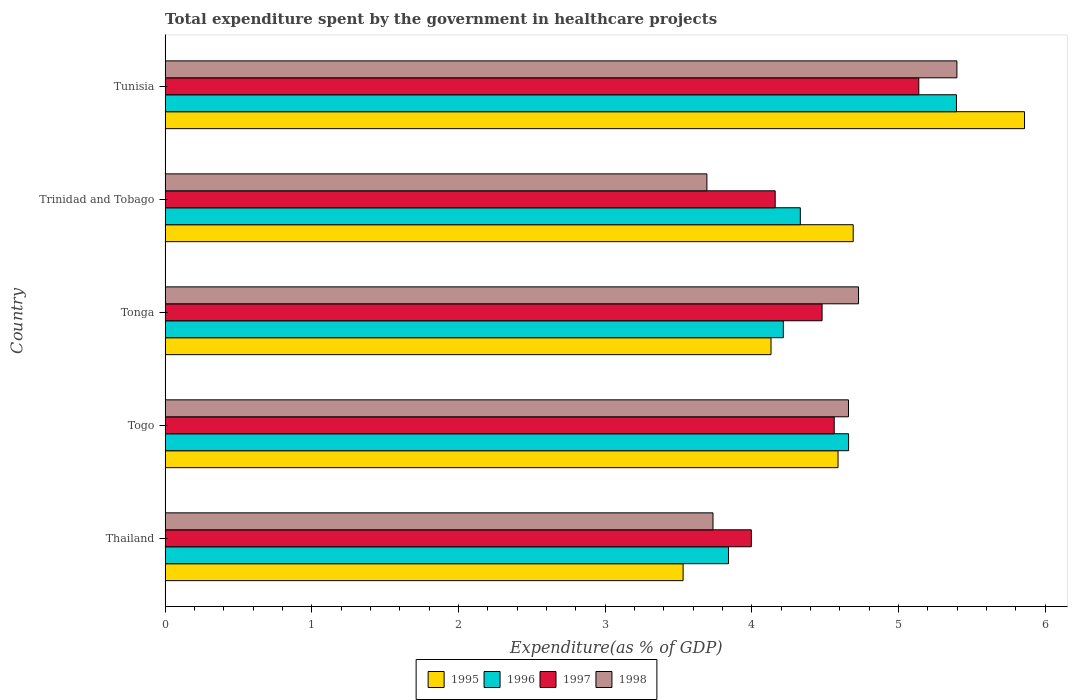How many different coloured bars are there?
Your response must be concise. 4. How many bars are there on the 5th tick from the bottom?
Provide a short and direct response. 4. What is the label of the 2nd group of bars from the top?
Ensure brevity in your answer.  Trinidad and Tobago. What is the total expenditure spent by the government in healthcare projects in 1995 in Togo?
Provide a succinct answer. 4.59. Across all countries, what is the maximum total expenditure spent by the government in healthcare projects in 1997?
Offer a very short reply. 5.14. Across all countries, what is the minimum total expenditure spent by the government in healthcare projects in 1995?
Offer a terse response. 3.53. In which country was the total expenditure spent by the government in healthcare projects in 1998 maximum?
Offer a very short reply. Tunisia. In which country was the total expenditure spent by the government in healthcare projects in 1995 minimum?
Your response must be concise. Thailand. What is the total total expenditure spent by the government in healthcare projects in 1997 in the graph?
Offer a terse response. 22.33. What is the difference between the total expenditure spent by the government in healthcare projects in 1998 in Thailand and that in Tonga?
Your answer should be compact. -0.99. What is the difference between the total expenditure spent by the government in healthcare projects in 1996 in Tunisia and the total expenditure spent by the government in healthcare projects in 1995 in Togo?
Offer a terse response. 0.81. What is the average total expenditure spent by the government in healthcare projects in 1998 per country?
Your response must be concise. 4.44. What is the difference between the total expenditure spent by the government in healthcare projects in 1998 and total expenditure spent by the government in healthcare projects in 1995 in Tonga?
Offer a very short reply. 0.6. In how many countries, is the total expenditure spent by the government in healthcare projects in 1996 greater than 1.6 %?
Your answer should be very brief. 5. What is the ratio of the total expenditure spent by the government in healthcare projects in 1998 in Thailand to that in Trinidad and Tobago?
Your answer should be very brief. 1.01. Is the total expenditure spent by the government in healthcare projects in 1997 in Thailand less than that in Trinidad and Tobago?
Make the answer very short. Yes. What is the difference between the highest and the second highest total expenditure spent by the government in healthcare projects in 1996?
Ensure brevity in your answer.  0.74. What is the difference between the highest and the lowest total expenditure spent by the government in healthcare projects in 1998?
Keep it short and to the point. 1.7. In how many countries, is the total expenditure spent by the government in healthcare projects in 1995 greater than the average total expenditure spent by the government in healthcare projects in 1995 taken over all countries?
Make the answer very short. 3. Is it the case that in every country, the sum of the total expenditure spent by the government in healthcare projects in 1996 and total expenditure spent by the government in healthcare projects in 1997 is greater than the sum of total expenditure spent by the government in healthcare projects in 1998 and total expenditure spent by the government in healthcare projects in 1995?
Provide a succinct answer. Yes. How many bars are there?
Give a very brief answer. 20. Are all the bars in the graph horizontal?
Keep it short and to the point. Yes. How many countries are there in the graph?
Offer a terse response. 5. Are the values on the major ticks of X-axis written in scientific E-notation?
Provide a succinct answer. No. Where does the legend appear in the graph?
Offer a terse response. Bottom center. How many legend labels are there?
Make the answer very short. 4. How are the legend labels stacked?
Offer a terse response. Horizontal. What is the title of the graph?
Your answer should be compact. Total expenditure spent by the government in healthcare projects. What is the label or title of the X-axis?
Keep it short and to the point. Expenditure(as % of GDP). What is the label or title of the Y-axis?
Give a very brief answer. Country. What is the Expenditure(as % of GDP) in 1995 in Thailand?
Make the answer very short. 3.53. What is the Expenditure(as % of GDP) in 1996 in Thailand?
Provide a succinct answer. 3.84. What is the Expenditure(as % of GDP) of 1997 in Thailand?
Give a very brief answer. 4. What is the Expenditure(as % of GDP) in 1998 in Thailand?
Your response must be concise. 3.74. What is the Expenditure(as % of GDP) in 1995 in Togo?
Give a very brief answer. 4.59. What is the Expenditure(as % of GDP) of 1996 in Togo?
Ensure brevity in your answer.  4.66. What is the Expenditure(as % of GDP) in 1997 in Togo?
Your answer should be compact. 4.56. What is the Expenditure(as % of GDP) of 1998 in Togo?
Offer a very short reply. 4.66. What is the Expenditure(as % of GDP) of 1995 in Tonga?
Provide a succinct answer. 4.13. What is the Expenditure(as % of GDP) in 1996 in Tonga?
Ensure brevity in your answer.  4.21. What is the Expenditure(as % of GDP) in 1997 in Tonga?
Your response must be concise. 4.48. What is the Expenditure(as % of GDP) of 1998 in Tonga?
Keep it short and to the point. 4.73. What is the Expenditure(as % of GDP) of 1995 in Trinidad and Tobago?
Your answer should be very brief. 4.69. What is the Expenditure(as % of GDP) of 1996 in Trinidad and Tobago?
Provide a short and direct response. 4.33. What is the Expenditure(as % of GDP) in 1997 in Trinidad and Tobago?
Your answer should be compact. 4.16. What is the Expenditure(as % of GDP) in 1998 in Trinidad and Tobago?
Make the answer very short. 3.69. What is the Expenditure(as % of GDP) of 1995 in Tunisia?
Give a very brief answer. 5.86. What is the Expenditure(as % of GDP) in 1996 in Tunisia?
Offer a terse response. 5.4. What is the Expenditure(as % of GDP) in 1997 in Tunisia?
Provide a succinct answer. 5.14. What is the Expenditure(as % of GDP) in 1998 in Tunisia?
Your answer should be very brief. 5.4. Across all countries, what is the maximum Expenditure(as % of GDP) of 1995?
Your response must be concise. 5.86. Across all countries, what is the maximum Expenditure(as % of GDP) of 1996?
Offer a very short reply. 5.4. Across all countries, what is the maximum Expenditure(as % of GDP) of 1997?
Keep it short and to the point. 5.14. Across all countries, what is the maximum Expenditure(as % of GDP) in 1998?
Offer a very short reply. 5.4. Across all countries, what is the minimum Expenditure(as % of GDP) of 1995?
Offer a terse response. 3.53. Across all countries, what is the minimum Expenditure(as % of GDP) in 1996?
Your answer should be very brief. 3.84. Across all countries, what is the minimum Expenditure(as % of GDP) of 1997?
Make the answer very short. 4. Across all countries, what is the minimum Expenditure(as % of GDP) of 1998?
Make the answer very short. 3.69. What is the total Expenditure(as % of GDP) of 1995 in the graph?
Keep it short and to the point. 22.8. What is the total Expenditure(as % of GDP) of 1996 in the graph?
Provide a succinct answer. 22.44. What is the total Expenditure(as % of GDP) in 1997 in the graph?
Your answer should be compact. 22.33. What is the total Expenditure(as % of GDP) of 1998 in the graph?
Ensure brevity in your answer.  22.21. What is the difference between the Expenditure(as % of GDP) in 1995 in Thailand and that in Togo?
Ensure brevity in your answer.  -1.06. What is the difference between the Expenditure(as % of GDP) in 1996 in Thailand and that in Togo?
Provide a short and direct response. -0.82. What is the difference between the Expenditure(as % of GDP) of 1997 in Thailand and that in Togo?
Your answer should be very brief. -0.56. What is the difference between the Expenditure(as % of GDP) in 1998 in Thailand and that in Togo?
Offer a very short reply. -0.92. What is the difference between the Expenditure(as % of GDP) of 1995 in Thailand and that in Tonga?
Your answer should be very brief. -0.6. What is the difference between the Expenditure(as % of GDP) in 1996 in Thailand and that in Tonga?
Your response must be concise. -0.37. What is the difference between the Expenditure(as % of GDP) of 1997 in Thailand and that in Tonga?
Make the answer very short. -0.48. What is the difference between the Expenditure(as % of GDP) in 1998 in Thailand and that in Tonga?
Make the answer very short. -0.99. What is the difference between the Expenditure(as % of GDP) of 1995 in Thailand and that in Trinidad and Tobago?
Keep it short and to the point. -1.16. What is the difference between the Expenditure(as % of GDP) of 1996 in Thailand and that in Trinidad and Tobago?
Ensure brevity in your answer.  -0.49. What is the difference between the Expenditure(as % of GDP) in 1997 in Thailand and that in Trinidad and Tobago?
Provide a succinct answer. -0.16. What is the difference between the Expenditure(as % of GDP) in 1998 in Thailand and that in Trinidad and Tobago?
Keep it short and to the point. 0.04. What is the difference between the Expenditure(as % of GDP) of 1995 in Thailand and that in Tunisia?
Ensure brevity in your answer.  -2.33. What is the difference between the Expenditure(as % of GDP) of 1996 in Thailand and that in Tunisia?
Your answer should be very brief. -1.55. What is the difference between the Expenditure(as % of GDP) in 1997 in Thailand and that in Tunisia?
Ensure brevity in your answer.  -1.14. What is the difference between the Expenditure(as % of GDP) in 1998 in Thailand and that in Tunisia?
Provide a short and direct response. -1.66. What is the difference between the Expenditure(as % of GDP) in 1995 in Togo and that in Tonga?
Your answer should be compact. 0.46. What is the difference between the Expenditure(as % of GDP) in 1996 in Togo and that in Tonga?
Keep it short and to the point. 0.44. What is the difference between the Expenditure(as % of GDP) of 1997 in Togo and that in Tonga?
Provide a succinct answer. 0.08. What is the difference between the Expenditure(as % of GDP) of 1998 in Togo and that in Tonga?
Make the answer very short. -0.07. What is the difference between the Expenditure(as % of GDP) of 1995 in Togo and that in Trinidad and Tobago?
Your answer should be compact. -0.1. What is the difference between the Expenditure(as % of GDP) in 1996 in Togo and that in Trinidad and Tobago?
Provide a succinct answer. 0.33. What is the difference between the Expenditure(as % of GDP) of 1997 in Togo and that in Trinidad and Tobago?
Your answer should be compact. 0.4. What is the difference between the Expenditure(as % of GDP) in 1998 in Togo and that in Trinidad and Tobago?
Provide a short and direct response. 0.97. What is the difference between the Expenditure(as % of GDP) in 1995 in Togo and that in Tunisia?
Keep it short and to the point. -1.27. What is the difference between the Expenditure(as % of GDP) in 1996 in Togo and that in Tunisia?
Offer a terse response. -0.74. What is the difference between the Expenditure(as % of GDP) of 1997 in Togo and that in Tunisia?
Ensure brevity in your answer.  -0.58. What is the difference between the Expenditure(as % of GDP) in 1998 in Togo and that in Tunisia?
Offer a very short reply. -0.74. What is the difference between the Expenditure(as % of GDP) in 1995 in Tonga and that in Trinidad and Tobago?
Provide a short and direct response. -0.56. What is the difference between the Expenditure(as % of GDP) in 1996 in Tonga and that in Trinidad and Tobago?
Your response must be concise. -0.12. What is the difference between the Expenditure(as % of GDP) of 1997 in Tonga and that in Trinidad and Tobago?
Keep it short and to the point. 0.32. What is the difference between the Expenditure(as % of GDP) of 1998 in Tonga and that in Trinidad and Tobago?
Offer a very short reply. 1.03. What is the difference between the Expenditure(as % of GDP) in 1995 in Tonga and that in Tunisia?
Provide a succinct answer. -1.73. What is the difference between the Expenditure(as % of GDP) in 1996 in Tonga and that in Tunisia?
Your answer should be compact. -1.18. What is the difference between the Expenditure(as % of GDP) in 1997 in Tonga and that in Tunisia?
Offer a very short reply. -0.66. What is the difference between the Expenditure(as % of GDP) of 1998 in Tonga and that in Tunisia?
Offer a very short reply. -0.67. What is the difference between the Expenditure(as % of GDP) in 1995 in Trinidad and Tobago and that in Tunisia?
Make the answer very short. -1.17. What is the difference between the Expenditure(as % of GDP) in 1996 in Trinidad and Tobago and that in Tunisia?
Keep it short and to the point. -1.06. What is the difference between the Expenditure(as % of GDP) of 1997 in Trinidad and Tobago and that in Tunisia?
Offer a terse response. -0.98. What is the difference between the Expenditure(as % of GDP) in 1998 in Trinidad and Tobago and that in Tunisia?
Give a very brief answer. -1.7. What is the difference between the Expenditure(as % of GDP) of 1995 in Thailand and the Expenditure(as % of GDP) of 1996 in Togo?
Your response must be concise. -1.13. What is the difference between the Expenditure(as % of GDP) of 1995 in Thailand and the Expenditure(as % of GDP) of 1997 in Togo?
Make the answer very short. -1.03. What is the difference between the Expenditure(as % of GDP) in 1995 in Thailand and the Expenditure(as % of GDP) in 1998 in Togo?
Ensure brevity in your answer.  -1.13. What is the difference between the Expenditure(as % of GDP) in 1996 in Thailand and the Expenditure(as % of GDP) in 1997 in Togo?
Give a very brief answer. -0.72. What is the difference between the Expenditure(as % of GDP) of 1996 in Thailand and the Expenditure(as % of GDP) of 1998 in Togo?
Provide a succinct answer. -0.82. What is the difference between the Expenditure(as % of GDP) of 1997 in Thailand and the Expenditure(as % of GDP) of 1998 in Togo?
Offer a terse response. -0.66. What is the difference between the Expenditure(as % of GDP) in 1995 in Thailand and the Expenditure(as % of GDP) in 1996 in Tonga?
Ensure brevity in your answer.  -0.68. What is the difference between the Expenditure(as % of GDP) in 1995 in Thailand and the Expenditure(as % of GDP) in 1997 in Tonga?
Your answer should be compact. -0.95. What is the difference between the Expenditure(as % of GDP) of 1995 in Thailand and the Expenditure(as % of GDP) of 1998 in Tonga?
Give a very brief answer. -1.2. What is the difference between the Expenditure(as % of GDP) in 1996 in Thailand and the Expenditure(as % of GDP) in 1997 in Tonga?
Keep it short and to the point. -0.64. What is the difference between the Expenditure(as % of GDP) in 1996 in Thailand and the Expenditure(as % of GDP) in 1998 in Tonga?
Ensure brevity in your answer.  -0.89. What is the difference between the Expenditure(as % of GDP) in 1997 in Thailand and the Expenditure(as % of GDP) in 1998 in Tonga?
Ensure brevity in your answer.  -0.73. What is the difference between the Expenditure(as % of GDP) of 1995 in Thailand and the Expenditure(as % of GDP) of 1996 in Trinidad and Tobago?
Ensure brevity in your answer.  -0.8. What is the difference between the Expenditure(as % of GDP) of 1995 in Thailand and the Expenditure(as % of GDP) of 1997 in Trinidad and Tobago?
Keep it short and to the point. -0.63. What is the difference between the Expenditure(as % of GDP) in 1995 in Thailand and the Expenditure(as % of GDP) in 1998 in Trinidad and Tobago?
Your answer should be compact. -0.16. What is the difference between the Expenditure(as % of GDP) of 1996 in Thailand and the Expenditure(as % of GDP) of 1997 in Trinidad and Tobago?
Make the answer very short. -0.32. What is the difference between the Expenditure(as % of GDP) in 1996 in Thailand and the Expenditure(as % of GDP) in 1998 in Trinidad and Tobago?
Provide a succinct answer. 0.15. What is the difference between the Expenditure(as % of GDP) in 1997 in Thailand and the Expenditure(as % of GDP) in 1998 in Trinidad and Tobago?
Offer a very short reply. 0.3. What is the difference between the Expenditure(as % of GDP) of 1995 in Thailand and the Expenditure(as % of GDP) of 1996 in Tunisia?
Your response must be concise. -1.86. What is the difference between the Expenditure(as % of GDP) of 1995 in Thailand and the Expenditure(as % of GDP) of 1997 in Tunisia?
Ensure brevity in your answer.  -1.61. What is the difference between the Expenditure(as % of GDP) of 1995 in Thailand and the Expenditure(as % of GDP) of 1998 in Tunisia?
Give a very brief answer. -1.87. What is the difference between the Expenditure(as % of GDP) of 1996 in Thailand and the Expenditure(as % of GDP) of 1997 in Tunisia?
Ensure brevity in your answer.  -1.3. What is the difference between the Expenditure(as % of GDP) in 1996 in Thailand and the Expenditure(as % of GDP) in 1998 in Tunisia?
Ensure brevity in your answer.  -1.56. What is the difference between the Expenditure(as % of GDP) of 1997 in Thailand and the Expenditure(as % of GDP) of 1998 in Tunisia?
Ensure brevity in your answer.  -1.4. What is the difference between the Expenditure(as % of GDP) in 1995 in Togo and the Expenditure(as % of GDP) in 1996 in Tonga?
Your answer should be very brief. 0.37. What is the difference between the Expenditure(as % of GDP) in 1995 in Togo and the Expenditure(as % of GDP) in 1997 in Tonga?
Offer a terse response. 0.11. What is the difference between the Expenditure(as % of GDP) in 1995 in Togo and the Expenditure(as % of GDP) in 1998 in Tonga?
Your response must be concise. -0.14. What is the difference between the Expenditure(as % of GDP) in 1996 in Togo and the Expenditure(as % of GDP) in 1997 in Tonga?
Offer a terse response. 0.18. What is the difference between the Expenditure(as % of GDP) in 1996 in Togo and the Expenditure(as % of GDP) in 1998 in Tonga?
Provide a short and direct response. -0.07. What is the difference between the Expenditure(as % of GDP) in 1997 in Togo and the Expenditure(as % of GDP) in 1998 in Tonga?
Provide a succinct answer. -0.17. What is the difference between the Expenditure(as % of GDP) of 1995 in Togo and the Expenditure(as % of GDP) of 1996 in Trinidad and Tobago?
Ensure brevity in your answer.  0.26. What is the difference between the Expenditure(as % of GDP) of 1995 in Togo and the Expenditure(as % of GDP) of 1997 in Trinidad and Tobago?
Your answer should be compact. 0.43. What is the difference between the Expenditure(as % of GDP) in 1995 in Togo and the Expenditure(as % of GDP) in 1998 in Trinidad and Tobago?
Make the answer very short. 0.89. What is the difference between the Expenditure(as % of GDP) in 1996 in Togo and the Expenditure(as % of GDP) in 1997 in Trinidad and Tobago?
Give a very brief answer. 0.5. What is the difference between the Expenditure(as % of GDP) of 1997 in Togo and the Expenditure(as % of GDP) of 1998 in Trinidad and Tobago?
Your answer should be very brief. 0.87. What is the difference between the Expenditure(as % of GDP) in 1995 in Togo and the Expenditure(as % of GDP) in 1996 in Tunisia?
Your response must be concise. -0.81. What is the difference between the Expenditure(as % of GDP) in 1995 in Togo and the Expenditure(as % of GDP) in 1997 in Tunisia?
Provide a succinct answer. -0.55. What is the difference between the Expenditure(as % of GDP) of 1995 in Togo and the Expenditure(as % of GDP) of 1998 in Tunisia?
Give a very brief answer. -0.81. What is the difference between the Expenditure(as % of GDP) of 1996 in Togo and the Expenditure(as % of GDP) of 1997 in Tunisia?
Give a very brief answer. -0.48. What is the difference between the Expenditure(as % of GDP) of 1996 in Togo and the Expenditure(as % of GDP) of 1998 in Tunisia?
Your answer should be compact. -0.74. What is the difference between the Expenditure(as % of GDP) in 1997 in Togo and the Expenditure(as % of GDP) in 1998 in Tunisia?
Keep it short and to the point. -0.84. What is the difference between the Expenditure(as % of GDP) in 1995 in Tonga and the Expenditure(as % of GDP) in 1996 in Trinidad and Tobago?
Give a very brief answer. -0.2. What is the difference between the Expenditure(as % of GDP) in 1995 in Tonga and the Expenditure(as % of GDP) in 1997 in Trinidad and Tobago?
Your answer should be compact. -0.03. What is the difference between the Expenditure(as % of GDP) in 1995 in Tonga and the Expenditure(as % of GDP) in 1998 in Trinidad and Tobago?
Give a very brief answer. 0.44. What is the difference between the Expenditure(as % of GDP) of 1996 in Tonga and the Expenditure(as % of GDP) of 1997 in Trinidad and Tobago?
Offer a very short reply. 0.06. What is the difference between the Expenditure(as % of GDP) in 1996 in Tonga and the Expenditure(as % of GDP) in 1998 in Trinidad and Tobago?
Give a very brief answer. 0.52. What is the difference between the Expenditure(as % of GDP) of 1997 in Tonga and the Expenditure(as % of GDP) of 1998 in Trinidad and Tobago?
Offer a very short reply. 0.79. What is the difference between the Expenditure(as % of GDP) of 1995 in Tonga and the Expenditure(as % of GDP) of 1996 in Tunisia?
Keep it short and to the point. -1.26. What is the difference between the Expenditure(as % of GDP) of 1995 in Tonga and the Expenditure(as % of GDP) of 1997 in Tunisia?
Offer a very short reply. -1.01. What is the difference between the Expenditure(as % of GDP) in 1995 in Tonga and the Expenditure(as % of GDP) in 1998 in Tunisia?
Your answer should be very brief. -1.27. What is the difference between the Expenditure(as % of GDP) in 1996 in Tonga and the Expenditure(as % of GDP) in 1997 in Tunisia?
Your answer should be very brief. -0.92. What is the difference between the Expenditure(as % of GDP) in 1996 in Tonga and the Expenditure(as % of GDP) in 1998 in Tunisia?
Ensure brevity in your answer.  -1.18. What is the difference between the Expenditure(as % of GDP) of 1997 in Tonga and the Expenditure(as % of GDP) of 1998 in Tunisia?
Make the answer very short. -0.92. What is the difference between the Expenditure(as % of GDP) in 1995 in Trinidad and Tobago and the Expenditure(as % of GDP) in 1996 in Tunisia?
Make the answer very short. -0.7. What is the difference between the Expenditure(as % of GDP) in 1995 in Trinidad and Tobago and the Expenditure(as % of GDP) in 1997 in Tunisia?
Your response must be concise. -0.45. What is the difference between the Expenditure(as % of GDP) of 1995 in Trinidad and Tobago and the Expenditure(as % of GDP) of 1998 in Tunisia?
Ensure brevity in your answer.  -0.71. What is the difference between the Expenditure(as % of GDP) in 1996 in Trinidad and Tobago and the Expenditure(as % of GDP) in 1997 in Tunisia?
Keep it short and to the point. -0.81. What is the difference between the Expenditure(as % of GDP) in 1996 in Trinidad and Tobago and the Expenditure(as % of GDP) in 1998 in Tunisia?
Your response must be concise. -1.07. What is the difference between the Expenditure(as % of GDP) in 1997 in Trinidad and Tobago and the Expenditure(as % of GDP) in 1998 in Tunisia?
Provide a succinct answer. -1.24. What is the average Expenditure(as % of GDP) in 1995 per country?
Your answer should be very brief. 4.56. What is the average Expenditure(as % of GDP) in 1996 per country?
Keep it short and to the point. 4.49. What is the average Expenditure(as % of GDP) in 1997 per country?
Provide a succinct answer. 4.47. What is the average Expenditure(as % of GDP) of 1998 per country?
Ensure brevity in your answer.  4.44. What is the difference between the Expenditure(as % of GDP) in 1995 and Expenditure(as % of GDP) in 1996 in Thailand?
Your answer should be compact. -0.31. What is the difference between the Expenditure(as % of GDP) of 1995 and Expenditure(as % of GDP) of 1997 in Thailand?
Your response must be concise. -0.47. What is the difference between the Expenditure(as % of GDP) in 1995 and Expenditure(as % of GDP) in 1998 in Thailand?
Offer a very short reply. -0.2. What is the difference between the Expenditure(as % of GDP) in 1996 and Expenditure(as % of GDP) in 1997 in Thailand?
Keep it short and to the point. -0.16. What is the difference between the Expenditure(as % of GDP) of 1996 and Expenditure(as % of GDP) of 1998 in Thailand?
Your answer should be compact. 0.11. What is the difference between the Expenditure(as % of GDP) in 1997 and Expenditure(as % of GDP) in 1998 in Thailand?
Keep it short and to the point. 0.26. What is the difference between the Expenditure(as % of GDP) in 1995 and Expenditure(as % of GDP) in 1996 in Togo?
Give a very brief answer. -0.07. What is the difference between the Expenditure(as % of GDP) of 1995 and Expenditure(as % of GDP) of 1997 in Togo?
Offer a very short reply. 0.03. What is the difference between the Expenditure(as % of GDP) in 1995 and Expenditure(as % of GDP) in 1998 in Togo?
Give a very brief answer. -0.07. What is the difference between the Expenditure(as % of GDP) in 1996 and Expenditure(as % of GDP) in 1997 in Togo?
Your answer should be compact. 0.1. What is the difference between the Expenditure(as % of GDP) in 1996 and Expenditure(as % of GDP) in 1998 in Togo?
Keep it short and to the point. 0. What is the difference between the Expenditure(as % of GDP) of 1997 and Expenditure(as % of GDP) of 1998 in Togo?
Your response must be concise. -0.1. What is the difference between the Expenditure(as % of GDP) of 1995 and Expenditure(as % of GDP) of 1996 in Tonga?
Ensure brevity in your answer.  -0.08. What is the difference between the Expenditure(as % of GDP) of 1995 and Expenditure(as % of GDP) of 1997 in Tonga?
Your answer should be very brief. -0.35. What is the difference between the Expenditure(as % of GDP) in 1995 and Expenditure(as % of GDP) in 1998 in Tonga?
Your answer should be very brief. -0.6. What is the difference between the Expenditure(as % of GDP) of 1996 and Expenditure(as % of GDP) of 1997 in Tonga?
Keep it short and to the point. -0.26. What is the difference between the Expenditure(as % of GDP) of 1996 and Expenditure(as % of GDP) of 1998 in Tonga?
Offer a very short reply. -0.51. What is the difference between the Expenditure(as % of GDP) of 1997 and Expenditure(as % of GDP) of 1998 in Tonga?
Your response must be concise. -0.25. What is the difference between the Expenditure(as % of GDP) in 1995 and Expenditure(as % of GDP) in 1996 in Trinidad and Tobago?
Keep it short and to the point. 0.36. What is the difference between the Expenditure(as % of GDP) of 1995 and Expenditure(as % of GDP) of 1997 in Trinidad and Tobago?
Make the answer very short. 0.53. What is the difference between the Expenditure(as % of GDP) in 1995 and Expenditure(as % of GDP) in 1998 in Trinidad and Tobago?
Your answer should be very brief. 1. What is the difference between the Expenditure(as % of GDP) in 1996 and Expenditure(as % of GDP) in 1997 in Trinidad and Tobago?
Ensure brevity in your answer.  0.17. What is the difference between the Expenditure(as % of GDP) of 1996 and Expenditure(as % of GDP) of 1998 in Trinidad and Tobago?
Offer a very short reply. 0.64. What is the difference between the Expenditure(as % of GDP) in 1997 and Expenditure(as % of GDP) in 1998 in Trinidad and Tobago?
Keep it short and to the point. 0.47. What is the difference between the Expenditure(as % of GDP) of 1995 and Expenditure(as % of GDP) of 1996 in Tunisia?
Your answer should be very brief. 0.46. What is the difference between the Expenditure(as % of GDP) in 1995 and Expenditure(as % of GDP) in 1997 in Tunisia?
Ensure brevity in your answer.  0.72. What is the difference between the Expenditure(as % of GDP) of 1995 and Expenditure(as % of GDP) of 1998 in Tunisia?
Keep it short and to the point. 0.46. What is the difference between the Expenditure(as % of GDP) of 1996 and Expenditure(as % of GDP) of 1997 in Tunisia?
Keep it short and to the point. 0.26. What is the difference between the Expenditure(as % of GDP) in 1996 and Expenditure(as % of GDP) in 1998 in Tunisia?
Provide a short and direct response. -0. What is the difference between the Expenditure(as % of GDP) in 1997 and Expenditure(as % of GDP) in 1998 in Tunisia?
Provide a short and direct response. -0.26. What is the ratio of the Expenditure(as % of GDP) in 1995 in Thailand to that in Togo?
Ensure brevity in your answer.  0.77. What is the ratio of the Expenditure(as % of GDP) in 1996 in Thailand to that in Togo?
Ensure brevity in your answer.  0.82. What is the ratio of the Expenditure(as % of GDP) in 1997 in Thailand to that in Togo?
Your answer should be very brief. 0.88. What is the ratio of the Expenditure(as % of GDP) in 1998 in Thailand to that in Togo?
Offer a terse response. 0.8. What is the ratio of the Expenditure(as % of GDP) in 1995 in Thailand to that in Tonga?
Ensure brevity in your answer.  0.85. What is the ratio of the Expenditure(as % of GDP) of 1996 in Thailand to that in Tonga?
Offer a very short reply. 0.91. What is the ratio of the Expenditure(as % of GDP) of 1997 in Thailand to that in Tonga?
Offer a terse response. 0.89. What is the ratio of the Expenditure(as % of GDP) of 1998 in Thailand to that in Tonga?
Your response must be concise. 0.79. What is the ratio of the Expenditure(as % of GDP) in 1995 in Thailand to that in Trinidad and Tobago?
Your answer should be compact. 0.75. What is the ratio of the Expenditure(as % of GDP) in 1996 in Thailand to that in Trinidad and Tobago?
Your response must be concise. 0.89. What is the ratio of the Expenditure(as % of GDP) of 1997 in Thailand to that in Trinidad and Tobago?
Your answer should be very brief. 0.96. What is the ratio of the Expenditure(as % of GDP) in 1998 in Thailand to that in Trinidad and Tobago?
Offer a very short reply. 1.01. What is the ratio of the Expenditure(as % of GDP) of 1995 in Thailand to that in Tunisia?
Your response must be concise. 0.6. What is the ratio of the Expenditure(as % of GDP) in 1996 in Thailand to that in Tunisia?
Your answer should be compact. 0.71. What is the ratio of the Expenditure(as % of GDP) in 1997 in Thailand to that in Tunisia?
Give a very brief answer. 0.78. What is the ratio of the Expenditure(as % of GDP) of 1998 in Thailand to that in Tunisia?
Keep it short and to the point. 0.69. What is the ratio of the Expenditure(as % of GDP) in 1995 in Togo to that in Tonga?
Offer a very short reply. 1.11. What is the ratio of the Expenditure(as % of GDP) in 1996 in Togo to that in Tonga?
Keep it short and to the point. 1.11. What is the ratio of the Expenditure(as % of GDP) in 1997 in Togo to that in Tonga?
Provide a succinct answer. 1.02. What is the ratio of the Expenditure(as % of GDP) in 1998 in Togo to that in Tonga?
Make the answer very short. 0.99. What is the ratio of the Expenditure(as % of GDP) in 1995 in Togo to that in Trinidad and Tobago?
Give a very brief answer. 0.98. What is the ratio of the Expenditure(as % of GDP) in 1996 in Togo to that in Trinidad and Tobago?
Keep it short and to the point. 1.08. What is the ratio of the Expenditure(as % of GDP) of 1997 in Togo to that in Trinidad and Tobago?
Keep it short and to the point. 1.1. What is the ratio of the Expenditure(as % of GDP) in 1998 in Togo to that in Trinidad and Tobago?
Your response must be concise. 1.26. What is the ratio of the Expenditure(as % of GDP) in 1995 in Togo to that in Tunisia?
Ensure brevity in your answer.  0.78. What is the ratio of the Expenditure(as % of GDP) in 1996 in Togo to that in Tunisia?
Your response must be concise. 0.86. What is the ratio of the Expenditure(as % of GDP) of 1997 in Togo to that in Tunisia?
Provide a succinct answer. 0.89. What is the ratio of the Expenditure(as % of GDP) of 1998 in Togo to that in Tunisia?
Give a very brief answer. 0.86. What is the ratio of the Expenditure(as % of GDP) in 1995 in Tonga to that in Trinidad and Tobago?
Ensure brevity in your answer.  0.88. What is the ratio of the Expenditure(as % of GDP) in 1996 in Tonga to that in Trinidad and Tobago?
Your response must be concise. 0.97. What is the ratio of the Expenditure(as % of GDP) of 1997 in Tonga to that in Trinidad and Tobago?
Provide a succinct answer. 1.08. What is the ratio of the Expenditure(as % of GDP) of 1998 in Tonga to that in Trinidad and Tobago?
Your answer should be compact. 1.28. What is the ratio of the Expenditure(as % of GDP) of 1995 in Tonga to that in Tunisia?
Provide a short and direct response. 0.7. What is the ratio of the Expenditure(as % of GDP) in 1996 in Tonga to that in Tunisia?
Give a very brief answer. 0.78. What is the ratio of the Expenditure(as % of GDP) of 1997 in Tonga to that in Tunisia?
Make the answer very short. 0.87. What is the ratio of the Expenditure(as % of GDP) of 1998 in Tonga to that in Tunisia?
Give a very brief answer. 0.88. What is the ratio of the Expenditure(as % of GDP) in 1995 in Trinidad and Tobago to that in Tunisia?
Your response must be concise. 0.8. What is the ratio of the Expenditure(as % of GDP) of 1996 in Trinidad and Tobago to that in Tunisia?
Give a very brief answer. 0.8. What is the ratio of the Expenditure(as % of GDP) of 1997 in Trinidad and Tobago to that in Tunisia?
Provide a short and direct response. 0.81. What is the ratio of the Expenditure(as % of GDP) in 1998 in Trinidad and Tobago to that in Tunisia?
Provide a succinct answer. 0.68. What is the difference between the highest and the second highest Expenditure(as % of GDP) in 1995?
Your response must be concise. 1.17. What is the difference between the highest and the second highest Expenditure(as % of GDP) of 1996?
Ensure brevity in your answer.  0.74. What is the difference between the highest and the second highest Expenditure(as % of GDP) of 1997?
Provide a short and direct response. 0.58. What is the difference between the highest and the second highest Expenditure(as % of GDP) of 1998?
Provide a short and direct response. 0.67. What is the difference between the highest and the lowest Expenditure(as % of GDP) of 1995?
Offer a very short reply. 2.33. What is the difference between the highest and the lowest Expenditure(as % of GDP) in 1996?
Your response must be concise. 1.55. What is the difference between the highest and the lowest Expenditure(as % of GDP) of 1997?
Provide a short and direct response. 1.14. What is the difference between the highest and the lowest Expenditure(as % of GDP) in 1998?
Provide a short and direct response. 1.7. 